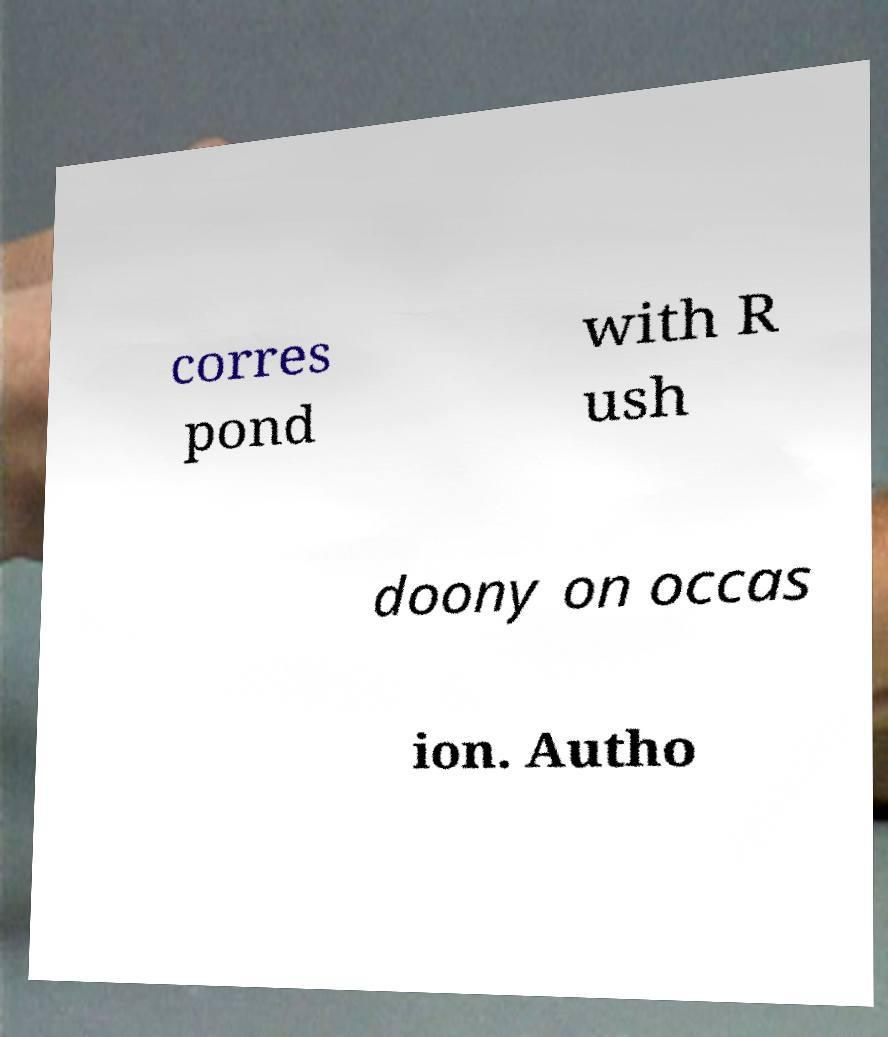There's text embedded in this image that I need extracted. Can you transcribe it verbatim? corres pond with R ush doony on occas ion. Autho 